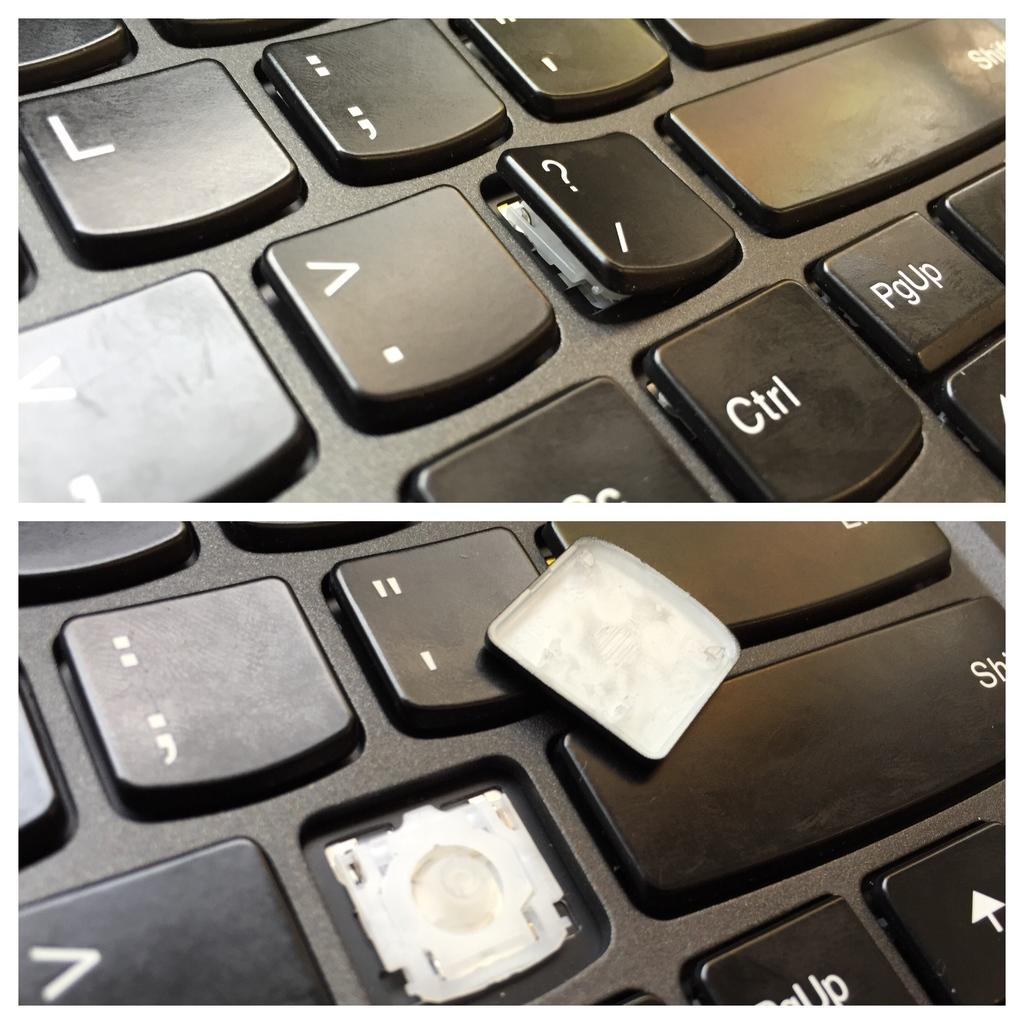<image>
Write a terse but informative summary of the picture. A keyboard has a broken ? key but the Ctrl key is fine. 